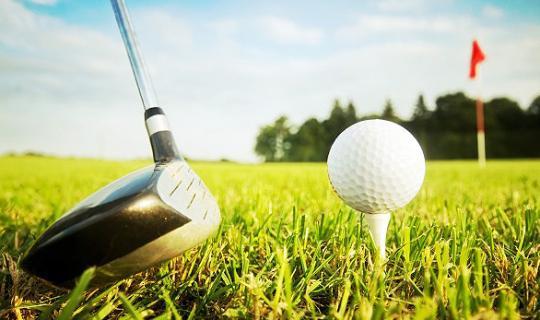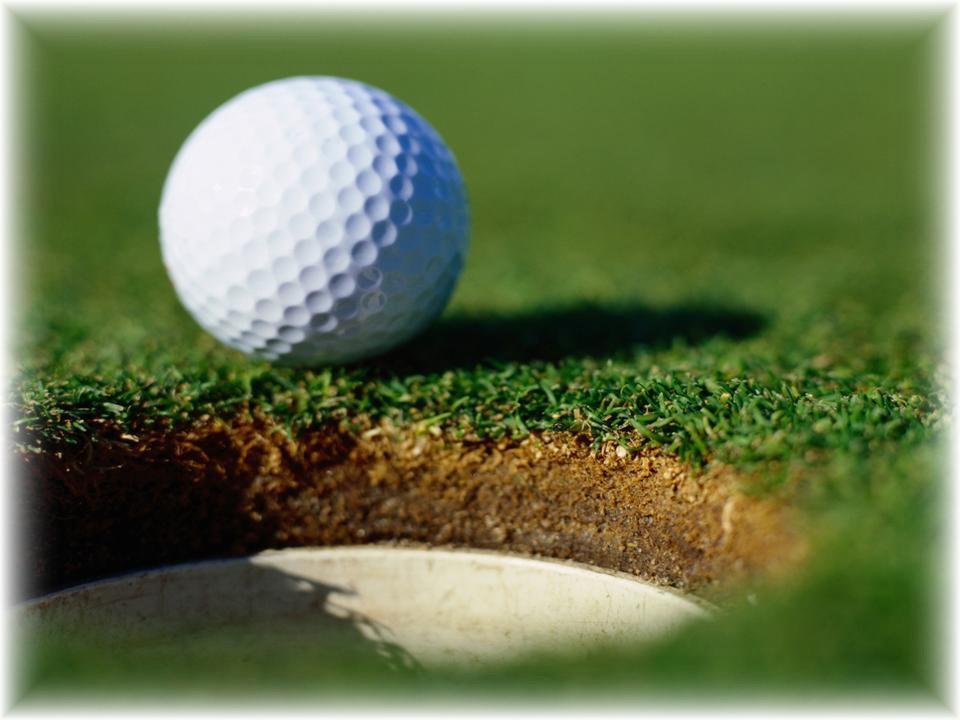The first image is the image on the left, the second image is the image on the right. Evaluate the accuracy of this statement regarding the images: "Golf clubs are near the ball in both images.". Is it true? Answer yes or no. No. The first image is the image on the left, the second image is the image on the right. Assess this claim about the two images: "Both golf balls have a golf club next to them.". Correct or not? Answer yes or no. No. 